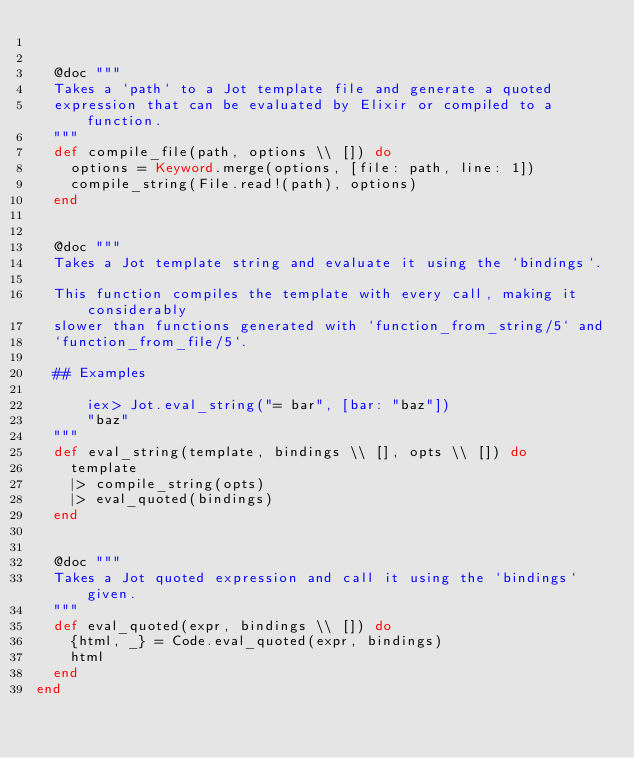<code> <loc_0><loc_0><loc_500><loc_500><_Elixir_>

  @doc """
  Takes a `path` to a Jot template file and generate a quoted
  expression that can be evaluated by Elixir or compiled to a function.
  """
  def compile_file(path, options \\ []) do
    options = Keyword.merge(options, [file: path, line: 1])
    compile_string(File.read!(path), options)
  end


  @doc """
  Takes a Jot template string and evaluate it using the `bindings`.

  This function compiles the template with every call, making it considerably
  slower than functions generated with `function_from_string/5` and
  `function_from_file/5`.

  ## Examples

      iex> Jot.eval_string("= bar", [bar: "baz"])
      "baz"
  """
  def eval_string(template, bindings \\ [], opts \\ []) do
    template
    |> compile_string(opts)
    |> eval_quoted(bindings)
  end


  @doc """
  Takes a Jot quoted expression and call it using the `bindings` given.
  """
  def eval_quoted(expr, bindings \\ []) do
    {html, _} = Code.eval_quoted(expr, bindings)
    html
  end
end
</code> 